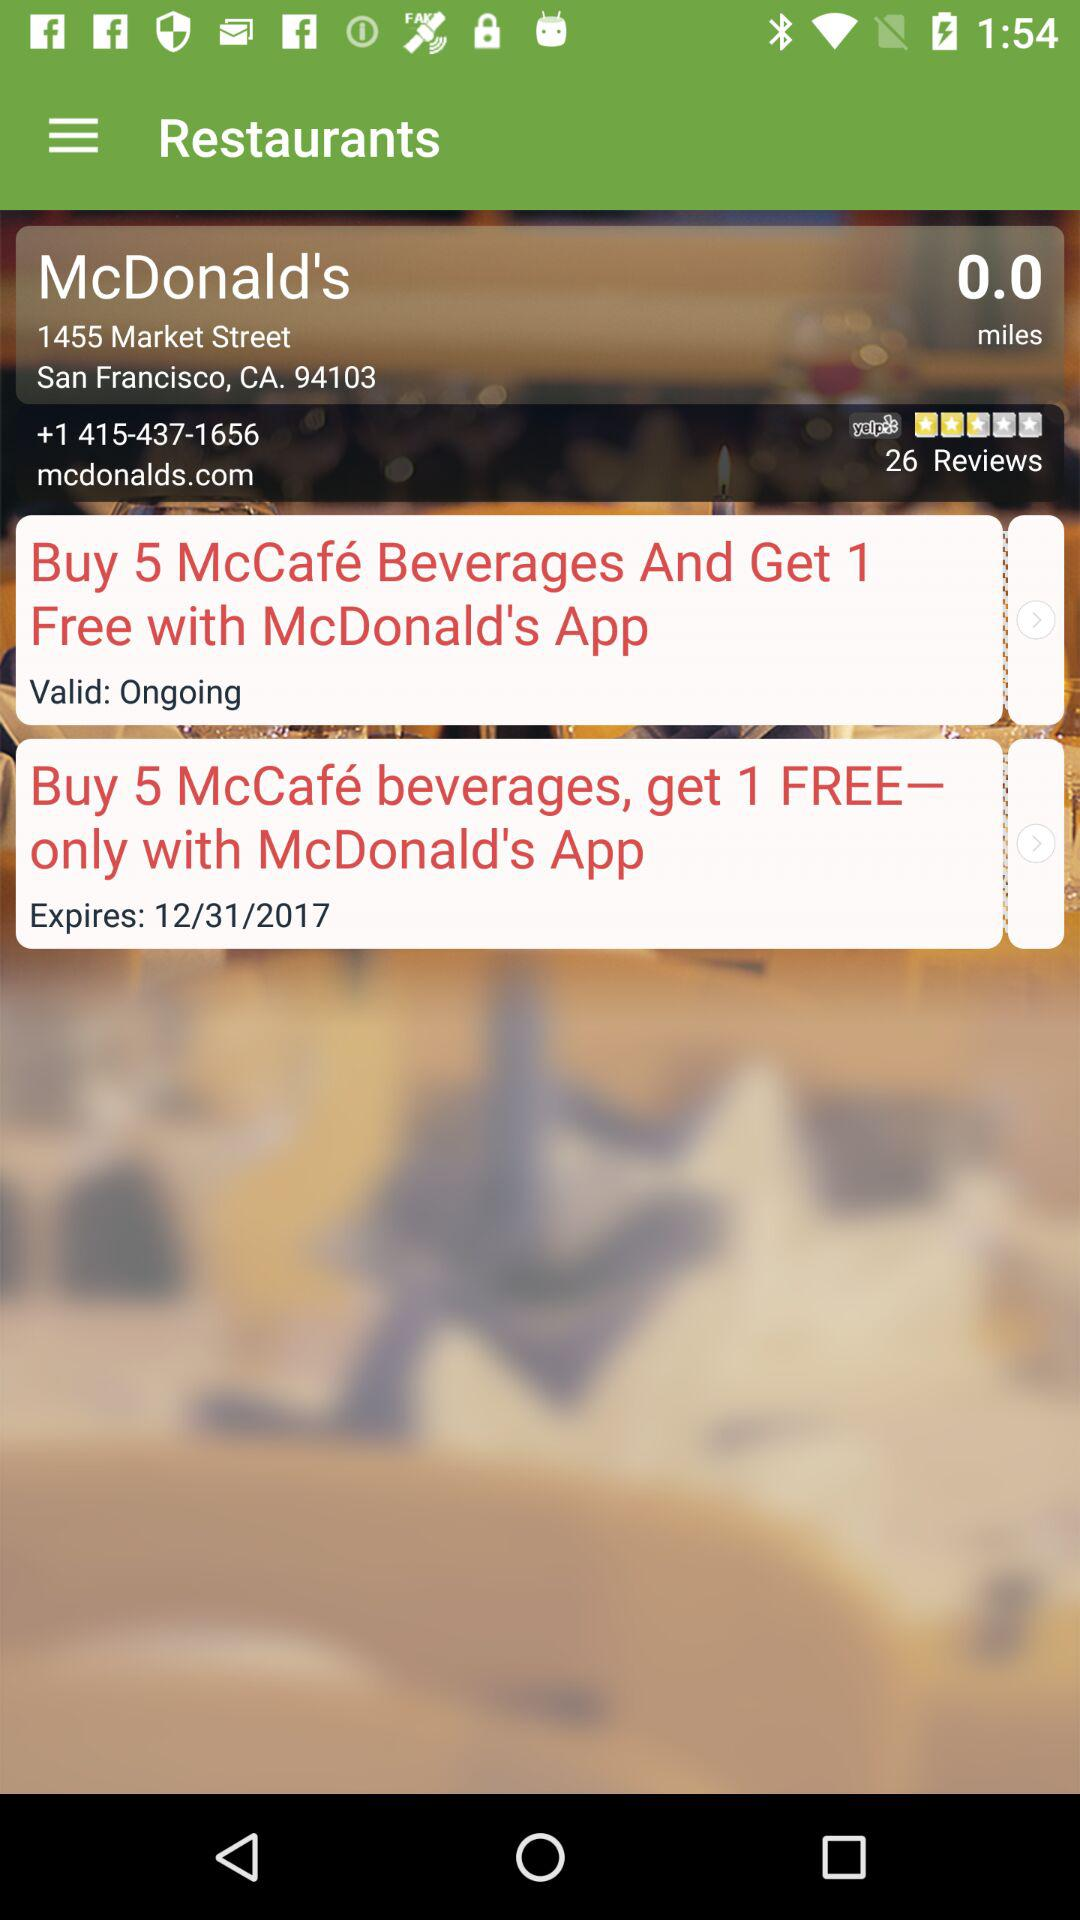How many people have rated "McDonald's"? The number of people who rated "McDonald's" is 26. 